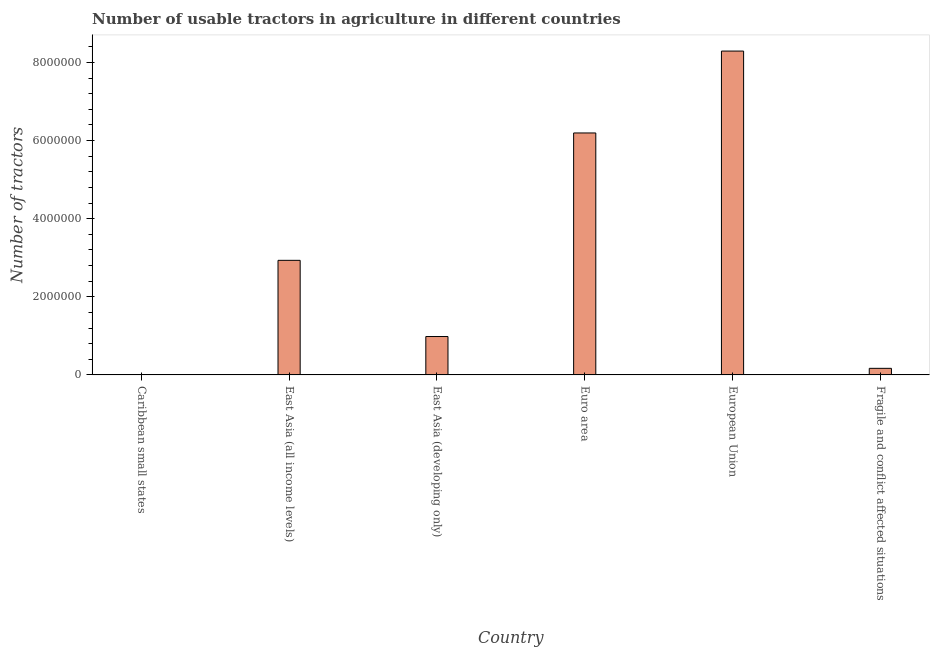Does the graph contain any zero values?
Offer a very short reply. No. What is the title of the graph?
Your response must be concise. Number of usable tractors in agriculture in different countries. What is the label or title of the Y-axis?
Offer a terse response. Number of tractors. What is the number of tractors in East Asia (developing only)?
Provide a short and direct response. 9.83e+05. Across all countries, what is the maximum number of tractors?
Give a very brief answer. 8.29e+06. Across all countries, what is the minimum number of tractors?
Offer a very short reply. 7316. In which country was the number of tractors minimum?
Your response must be concise. Caribbean small states. What is the sum of the number of tractors?
Provide a short and direct response. 1.86e+07. What is the difference between the number of tractors in East Asia (all income levels) and East Asia (developing only)?
Provide a short and direct response. 1.95e+06. What is the average number of tractors per country?
Your answer should be very brief. 3.10e+06. What is the median number of tractors?
Give a very brief answer. 1.96e+06. In how many countries, is the number of tractors greater than 2000000 ?
Ensure brevity in your answer.  3. What is the ratio of the number of tractors in East Asia (developing only) to that in Fragile and conflict affected situations?
Your answer should be compact. 5.84. Is the number of tractors in East Asia (all income levels) less than that in European Union?
Provide a short and direct response. Yes. What is the difference between the highest and the second highest number of tractors?
Provide a succinct answer. 2.10e+06. What is the difference between the highest and the lowest number of tractors?
Your answer should be very brief. 8.28e+06. In how many countries, is the number of tractors greater than the average number of tractors taken over all countries?
Offer a very short reply. 2. How many bars are there?
Provide a succinct answer. 6. Are all the bars in the graph horizontal?
Your response must be concise. No. How many countries are there in the graph?
Make the answer very short. 6. Are the values on the major ticks of Y-axis written in scientific E-notation?
Your answer should be compact. No. What is the Number of tractors of Caribbean small states?
Make the answer very short. 7316. What is the Number of tractors in East Asia (all income levels)?
Your response must be concise. 2.93e+06. What is the Number of tractors of East Asia (developing only)?
Offer a terse response. 9.83e+05. What is the Number of tractors in Euro area?
Your answer should be very brief. 6.19e+06. What is the Number of tractors of European Union?
Your answer should be compact. 8.29e+06. What is the Number of tractors of Fragile and conflict affected situations?
Offer a terse response. 1.68e+05. What is the difference between the Number of tractors in Caribbean small states and East Asia (all income levels)?
Keep it short and to the point. -2.93e+06. What is the difference between the Number of tractors in Caribbean small states and East Asia (developing only)?
Offer a terse response. -9.76e+05. What is the difference between the Number of tractors in Caribbean small states and Euro area?
Make the answer very short. -6.19e+06. What is the difference between the Number of tractors in Caribbean small states and European Union?
Your answer should be compact. -8.28e+06. What is the difference between the Number of tractors in Caribbean small states and Fragile and conflict affected situations?
Provide a succinct answer. -1.61e+05. What is the difference between the Number of tractors in East Asia (all income levels) and East Asia (developing only)?
Provide a short and direct response. 1.95e+06. What is the difference between the Number of tractors in East Asia (all income levels) and Euro area?
Offer a very short reply. -3.26e+06. What is the difference between the Number of tractors in East Asia (all income levels) and European Union?
Make the answer very short. -5.36e+06. What is the difference between the Number of tractors in East Asia (all income levels) and Fragile and conflict affected situations?
Offer a very short reply. 2.76e+06. What is the difference between the Number of tractors in East Asia (developing only) and Euro area?
Keep it short and to the point. -5.21e+06. What is the difference between the Number of tractors in East Asia (developing only) and European Union?
Make the answer very short. -7.31e+06. What is the difference between the Number of tractors in East Asia (developing only) and Fragile and conflict affected situations?
Provide a succinct answer. 8.15e+05. What is the difference between the Number of tractors in Euro area and European Union?
Your response must be concise. -2.10e+06. What is the difference between the Number of tractors in Euro area and Fragile and conflict affected situations?
Your answer should be very brief. 6.03e+06. What is the difference between the Number of tractors in European Union and Fragile and conflict affected situations?
Keep it short and to the point. 8.12e+06. What is the ratio of the Number of tractors in Caribbean small states to that in East Asia (all income levels)?
Provide a succinct answer. 0. What is the ratio of the Number of tractors in Caribbean small states to that in East Asia (developing only)?
Your response must be concise. 0.01. What is the ratio of the Number of tractors in Caribbean small states to that in Euro area?
Keep it short and to the point. 0. What is the ratio of the Number of tractors in Caribbean small states to that in European Union?
Your response must be concise. 0. What is the ratio of the Number of tractors in Caribbean small states to that in Fragile and conflict affected situations?
Offer a terse response. 0.04. What is the ratio of the Number of tractors in East Asia (all income levels) to that in East Asia (developing only)?
Provide a short and direct response. 2.98. What is the ratio of the Number of tractors in East Asia (all income levels) to that in Euro area?
Offer a terse response. 0.47. What is the ratio of the Number of tractors in East Asia (all income levels) to that in European Union?
Keep it short and to the point. 0.35. What is the ratio of the Number of tractors in East Asia (all income levels) to that in Fragile and conflict affected situations?
Offer a very short reply. 17.44. What is the ratio of the Number of tractors in East Asia (developing only) to that in Euro area?
Ensure brevity in your answer.  0.16. What is the ratio of the Number of tractors in East Asia (developing only) to that in European Union?
Your answer should be very brief. 0.12. What is the ratio of the Number of tractors in East Asia (developing only) to that in Fragile and conflict affected situations?
Keep it short and to the point. 5.84. What is the ratio of the Number of tractors in Euro area to that in European Union?
Give a very brief answer. 0.75. What is the ratio of the Number of tractors in Euro area to that in Fragile and conflict affected situations?
Make the answer very short. 36.82. What is the ratio of the Number of tractors in European Union to that in Fragile and conflict affected situations?
Keep it short and to the point. 49.29. 